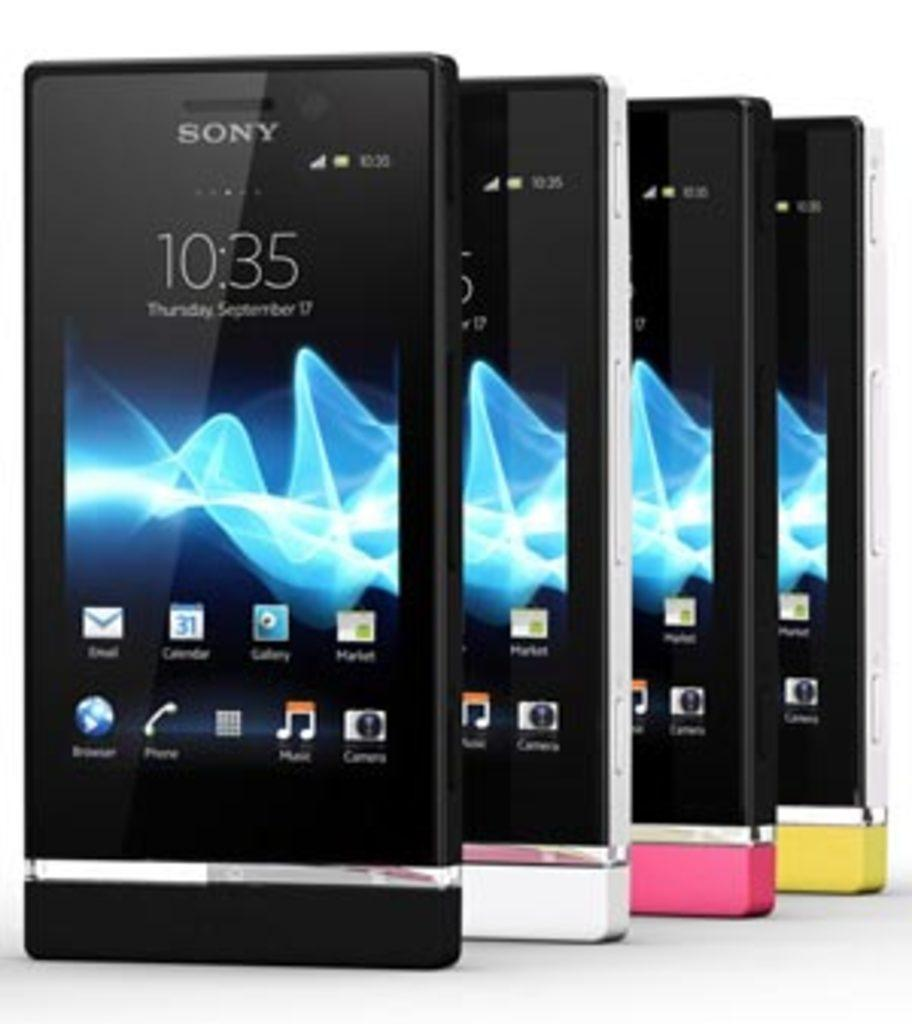<image>
Provide a brief description of the given image. Several Sony mobile devices sit in front of a white background at 10:35 on Septmber 17. 